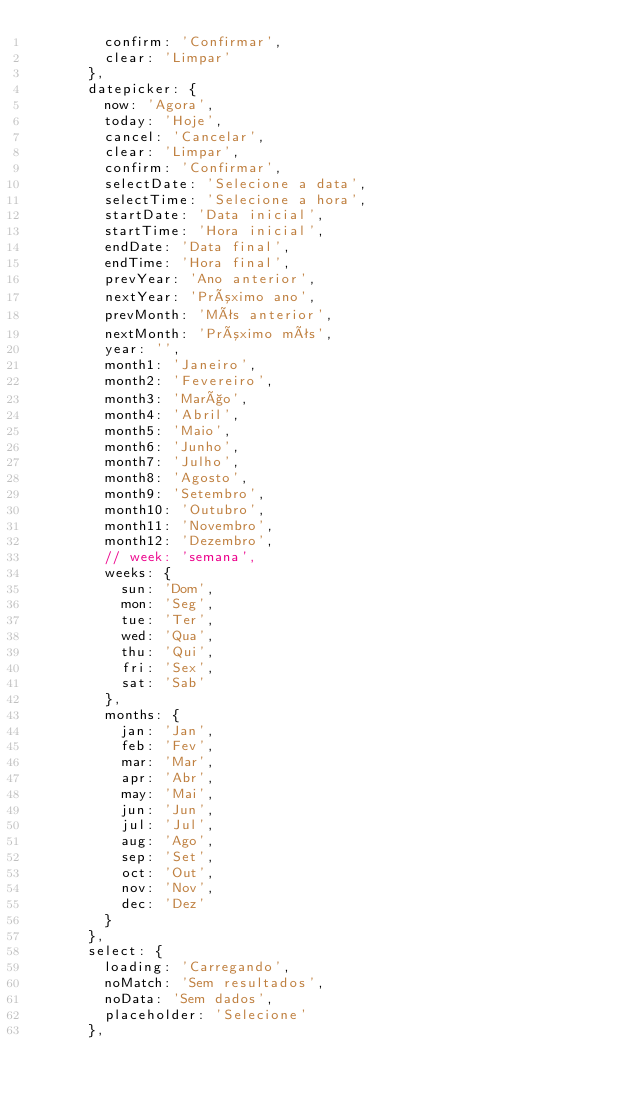<code> <loc_0><loc_0><loc_500><loc_500><_JavaScript_>        confirm: 'Confirmar',
        clear: 'Limpar'
      },
      datepicker: {
        now: 'Agora',
        today: 'Hoje',
        cancel: 'Cancelar',
        clear: 'Limpar',
        confirm: 'Confirmar',
        selectDate: 'Selecione a data',
        selectTime: 'Selecione a hora',
        startDate: 'Data inicial',
        startTime: 'Hora inicial',
        endDate: 'Data final',
        endTime: 'Hora final',
        prevYear: 'Ano anterior',
        nextYear: 'Próximo ano',
        prevMonth: 'Mês anterior',
        nextMonth: 'Próximo mês',
        year: '',
        month1: 'Janeiro',
        month2: 'Fevereiro',
        month3: 'Março',
        month4: 'Abril',
        month5: 'Maio',
        month6: 'Junho',
        month7: 'Julho',
        month8: 'Agosto',
        month9: 'Setembro',
        month10: 'Outubro',
        month11: 'Novembro',
        month12: 'Dezembro',
        // week: 'semana',
        weeks: {
          sun: 'Dom',
          mon: 'Seg',
          tue: 'Ter',
          wed: 'Qua',
          thu: 'Qui',
          fri: 'Sex',
          sat: 'Sab'
        },
        months: {
          jan: 'Jan',
          feb: 'Fev',
          mar: 'Mar',
          apr: 'Abr',
          may: 'Mai',
          jun: 'Jun',
          jul: 'Jul',
          aug: 'Ago',
          sep: 'Set',
          oct: 'Out',
          nov: 'Nov',
          dec: 'Dez'
        }
      },
      select: {
        loading: 'Carregando',
        noMatch: 'Sem resultados',
        noData: 'Sem dados',
        placeholder: 'Selecione'
      },</code> 